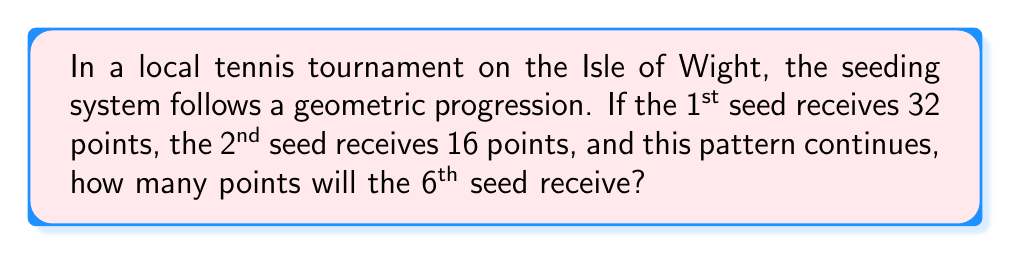Provide a solution to this math problem. Let's approach this step-by-step:

1) We can see that this is a geometric sequence, where each term is multiplied by a constant factor to get the next term.

2) Let's identify the first term and the common ratio:
   - First term (a): 32 points
   - Second term: 16 points

3) To find the common ratio (r), we divide the second term by the first term:
   $r = \frac{16}{32} = \frac{1}{2}$

4) Now we have a geometric sequence with:
   - First term: $a = 32$
   - Common ratio: $r = \frac{1}{2}$

5) The general formula for the nth term of a geometric sequence is:
   $a_n = a \cdot r^{n-1}$

6) We want to find the 6th term, so n = 6:
   $a_6 = 32 \cdot (\frac{1}{2})^{6-1}$

7) Let's calculate:
   $a_6 = 32 \cdot (\frac{1}{2})^5$
   $a_6 = 32 \cdot \frac{1}{32}$
   $a_6 = 1$

Therefore, the 6th seed will receive 1 point.
Answer: 1 point 